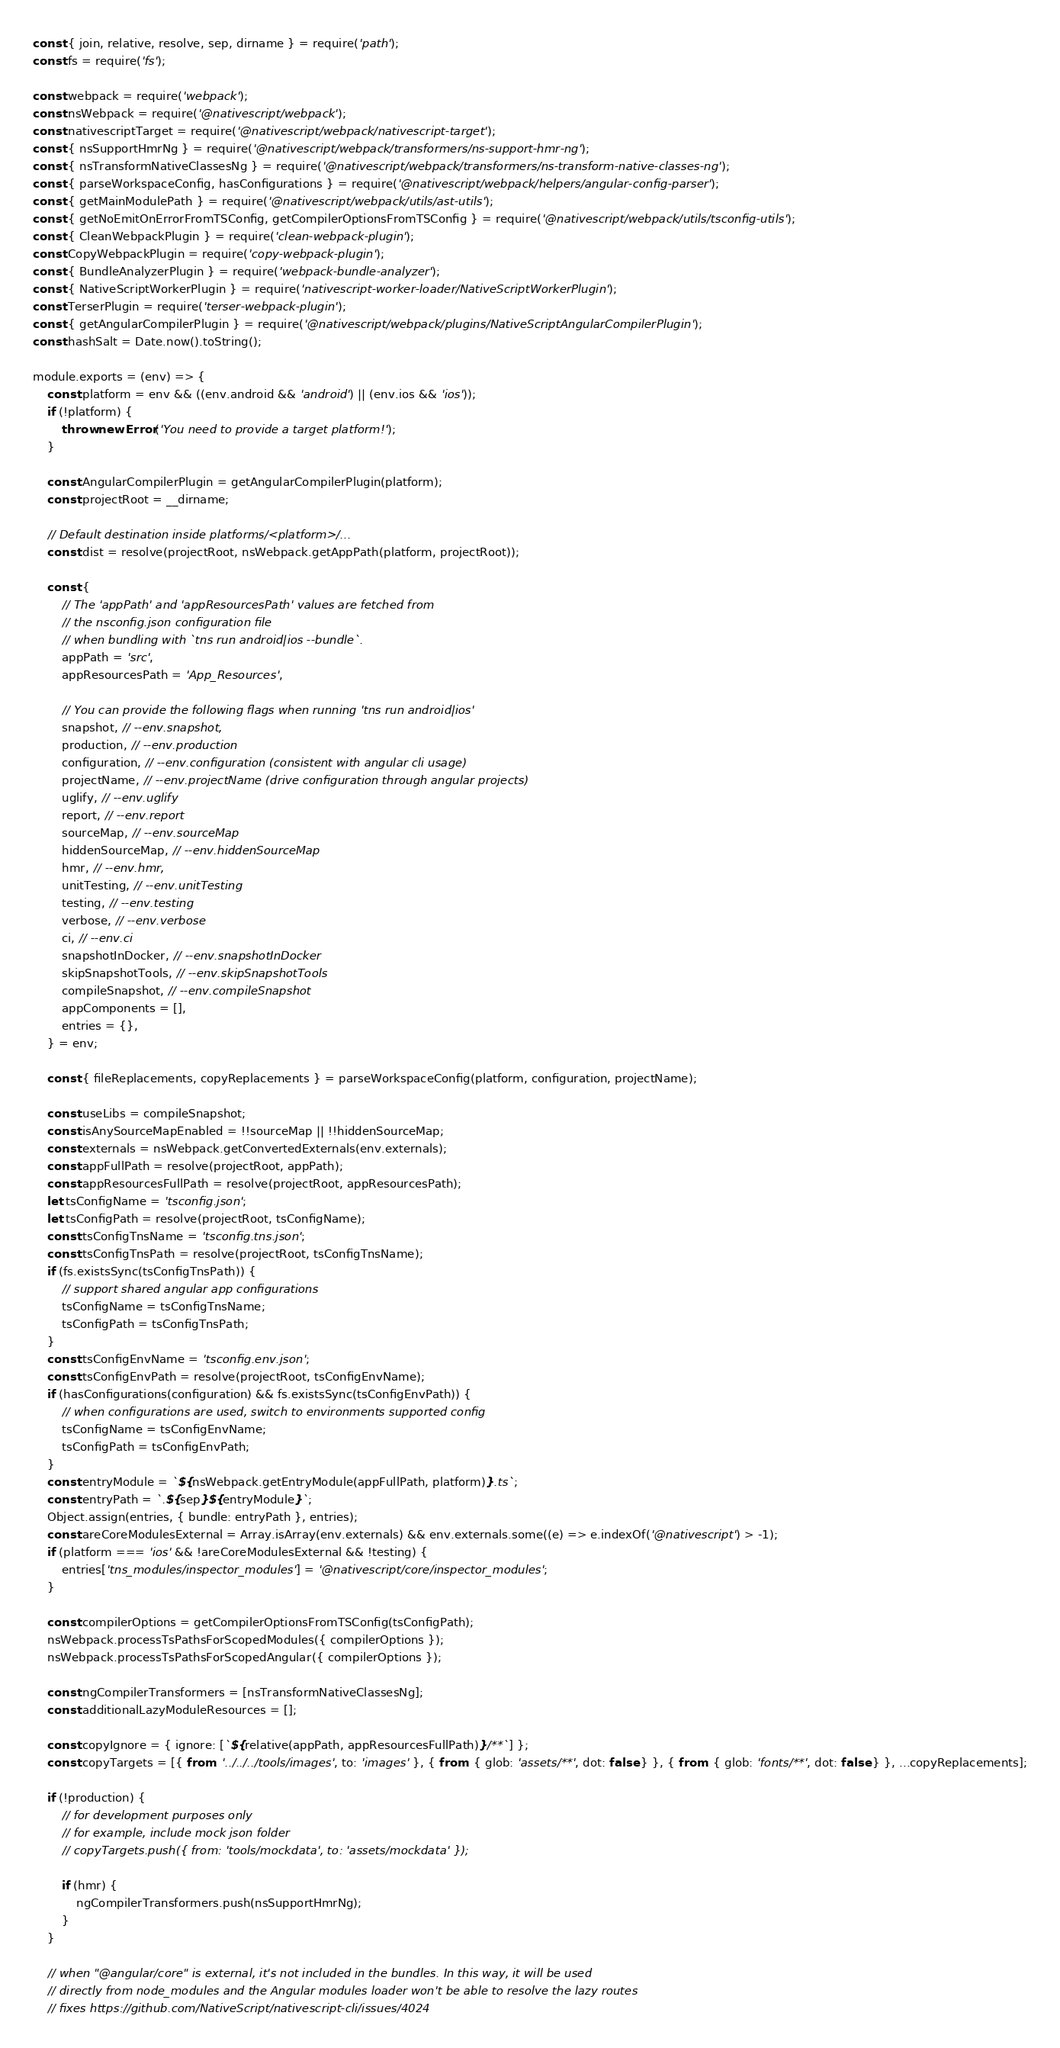Convert code to text. <code><loc_0><loc_0><loc_500><loc_500><_JavaScript_>const { join, relative, resolve, sep, dirname } = require('path');
const fs = require('fs');

const webpack = require('webpack');
const nsWebpack = require('@nativescript/webpack');
const nativescriptTarget = require('@nativescript/webpack/nativescript-target');
const { nsSupportHmrNg } = require('@nativescript/webpack/transformers/ns-support-hmr-ng');
const { nsTransformNativeClassesNg } = require('@nativescript/webpack/transformers/ns-transform-native-classes-ng');
const { parseWorkspaceConfig, hasConfigurations } = require('@nativescript/webpack/helpers/angular-config-parser');
const { getMainModulePath } = require('@nativescript/webpack/utils/ast-utils');
const { getNoEmitOnErrorFromTSConfig, getCompilerOptionsFromTSConfig } = require('@nativescript/webpack/utils/tsconfig-utils');
const { CleanWebpackPlugin } = require('clean-webpack-plugin');
const CopyWebpackPlugin = require('copy-webpack-plugin');
const { BundleAnalyzerPlugin } = require('webpack-bundle-analyzer');
const { NativeScriptWorkerPlugin } = require('nativescript-worker-loader/NativeScriptWorkerPlugin');
const TerserPlugin = require('terser-webpack-plugin');
const { getAngularCompilerPlugin } = require('@nativescript/webpack/plugins/NativeScriptAngularCompilerPlugin');
const hashSalt = Date.now().toString();

module.exports = (env) => {
	const platform = env && ((env.android && 'android') || (env.ios && 'ios'));
	if (!platform) {
		throw new Error('You need to provide a target platform!');
	}

	const AngularCompilerPlugin = getAngularCompilerPlugin(platform);
	const projectRoot = __dirname;

	// Default destination inside platforms/<platform>/...
	const dist = resolve(projectRoot, nsWebpack.getAppPath(platform, projectRoot));

	const {
		// The 'appPath' and 'appResourcesPath' values are fetched from
		// the nsconfig.json configuration file
		// when bundling with `tns run android|ios --bundle`.
		appPath = 'src',
		appResourcesPath = 'App_Resources',

		// You can provide the following flags when running 'tns run android|ios'
		snapshot, // --env.snapshot,
		production, // --env.production
		configuration, // --env.configuration (consistent with angular cli usage)
		projectName, // --env.projectName (drive configuration through angular projects)
		uglify, // --env.uglify
		report, // --env.report
		sourceMap, // --env.sourceMap
		hiddenSourceMap, // --env.hiddenSourceMap
		hmr, // --env.hmr,
		unitTesting, // --env.unitTesting
		testing, // --env.testing
		verbose, // --env.verbose
		ci, // --env.ci
		snapshotInDocker, // --env.snapshotInDocker
		skipSnapshotTools, // --env.skipSnapshotTools
		compileSnapshot, // --env.compileSnapshot
		appComponents = [],
		entries = {},
	} = env;

	const { fileReplacements, copyReplacements } = parseWorkspaceConfig(platform, configuration, projectName);

	const useLibs = compileSnapshot;
	const isAnySourceMapEnabled = !!sourceMap || !!hiddenSourceMap;
	const externals = nsWebpack.getConvertedExternals(env.externals);
	const appFullPath = resolve(projectRoot, appPath);
	const appResourcesFullPath = resolve(projectRoot, appResourcesPath);
	let tsConfigName = 'tsconfig.json';
	let tsConfigPath = resolve(projectRoot, tsConfigName);
	const tsConfigTnsName = 'tsconfig.tns.json';
	const tsConfigTnsPath = resolve(projectRoot, tsConfigTnsName);
	if (fs.existsSync(tsConfigTnsPath)) {
		// support shared angular app configurations
		tsConfigName = tsConfigTnsName;
		tsConfigPath = tsConfigTnsPath;
	}
	const tsConfigEnvName = 'tsconfig.env.json';
	const tsConfigEnvPath = resolve(projectRoot, tsConfigEnvName);
	if (hasConfigurations(configuration) && fs.existsSync(tsConfigEnvPath)) {
		// when configurations are used, switch to environments supported config
		tsConfigName = tsConfigEnvName;
		tsConfigPath = tsConfigEnvPath;
	}
	const entryModule = `${nsWebpack.getEntryModule(appFullPath, platform)}.ts`;
	const entryPath = `.${sep}${entryModule}`;
	Object.assign(entries, { bundle: entryPath }, entries);
	const areCoreModulesExternal = Array.isArray(env.externals) && env.externals.some((e) => e.indexOf('@nativescript') > -1);
	if (platform === 'ios' && !areCoreModulesExternal && !testing) {
		entries['tns_modules/inspector_modules'] = '@nativescript/core/inspector_modules';
	}

	const compilerOptions = getCompilerOptionsFromTSConfig(tsConfigPath);
	nsWebpack.processTsPathsForScopedModules({ compilerOptions });
	nsWebpack.processTsPathsForScopedAngular({ compilerOptions });

	const ngCompilerTransformers = [nsTransformNativeClassesNg];
	const additionalLazyModuleResources = [];

	const copyIgnore = { ignore: [`${relative(appPath, appResourcesFullPath)}/**`] };
	const copyTargets = [{ from: '../../../tools/images', to: 'images' }, { from: { glob: 'assets/**', dot: false } }, { from: { glob: 'fonts/**', dot: false } }, ...copyReplacements];

	if (!production) {
		// for development purposes only
		// for example, include mock json folder
		// copyTargets.push({ from: 'tools/mockdata', to: 'assets/mockdata' });

		if (hmr) {
			ngCompilerTransformers.push(nsSupportHmrNg);
		}
	}

	// when "@angular/core" is external, it's not included in the bundles. In this way, it will be used
	// directly from node_modules and the Angular modules loader won't be able to resolve the lazy routes
	// fixes https://github.com/NativeScript/nativescript-cli/issues/4024</code> 